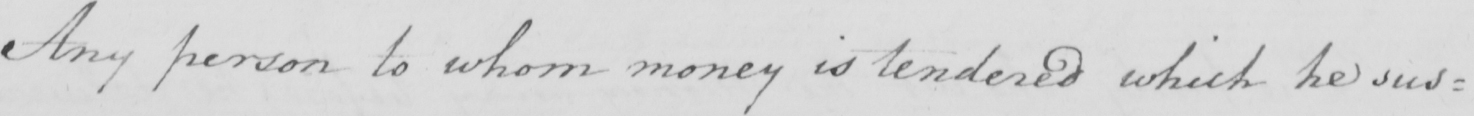What does this handwritten line say? Any person to whom money is tendered which he sus= 